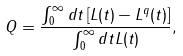Convert formula to latex. <formula><loc_0><loc_0><loc_500><loc_500>Q = \frac { \int _ { 0 } ^ { \infty } d t \left [ L ( t ) - L ^ { q } ( t ) \right ] } { \int _ { 0 } ^ { \infty } d t L ( t ) } ,</formula> 